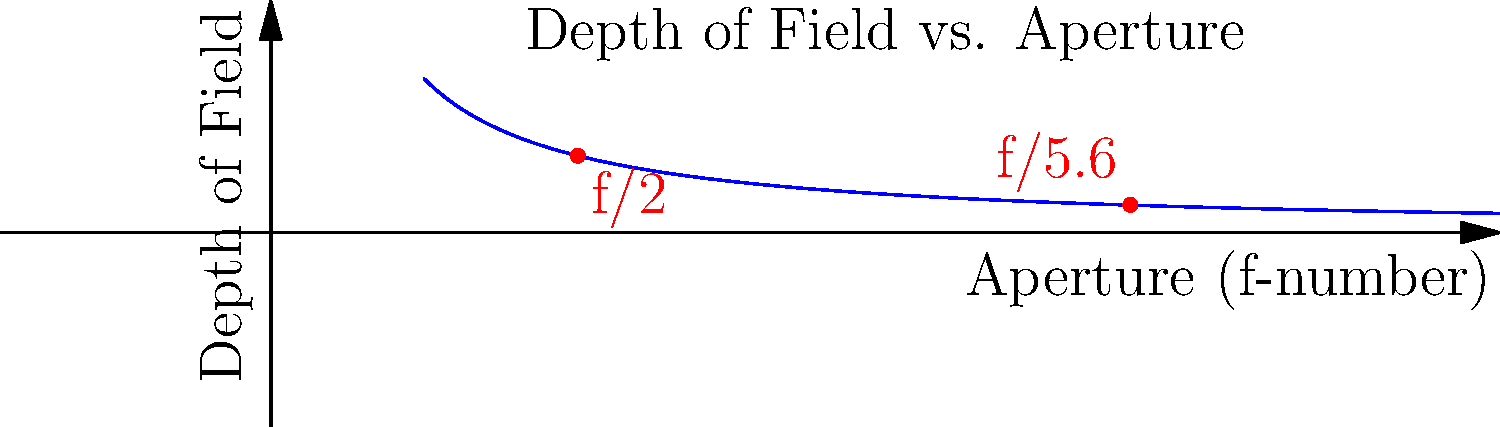Вы фотографируете семью вашего друга-руководителя стартапа на пикнике. У вас объектив с фокусным расстоянием 50 мм. При диафрагме f/2 глубина резкости составляет 0.5 м. Если вы хотите увеличить глубину резкости примерно в 3 раза, до какого значения нужно закрыть диафрагму? Чтобы решить эту задачу, выполним следующие шаги:

1) Глубина резкости обратно пропорциональна квадрату диафрагменного числа. Это можно выразить формулой:

   $$\text{DoF} \propto \frac{1}{f^2}$$

   где DoF - глубина резкости, а f - диафрагменное число.

2) Мы хотим увеличить глубину резкости в 3 раза. Пусть x - новое диафрагменное число. Тогда:

   $$\frac{\text{DoF}_\text{new}}{\text{DoF}_\text{old}} = \frac{x^2}{2^2} = 3$$

3) Решаем уравнение:

   $$\frac{x^2}{4} = 3$$
   $$x^2 = 12$$
   $$x = \sqrt{12} \approx 3.46$$

4) Ближайшее стандартное значение диафрагмы к 3.46 - это f/5.6.

5) Проверка: $(5.6/2)^2 = 7.84$, что близко к 3 (точное утроение было бы при f/3.46).

Таким образом, чтобы увеличить глубину резкости примерно в 3 раза, нужно закрыть диафрагму до f/5.6.
Answer: f/5.6 